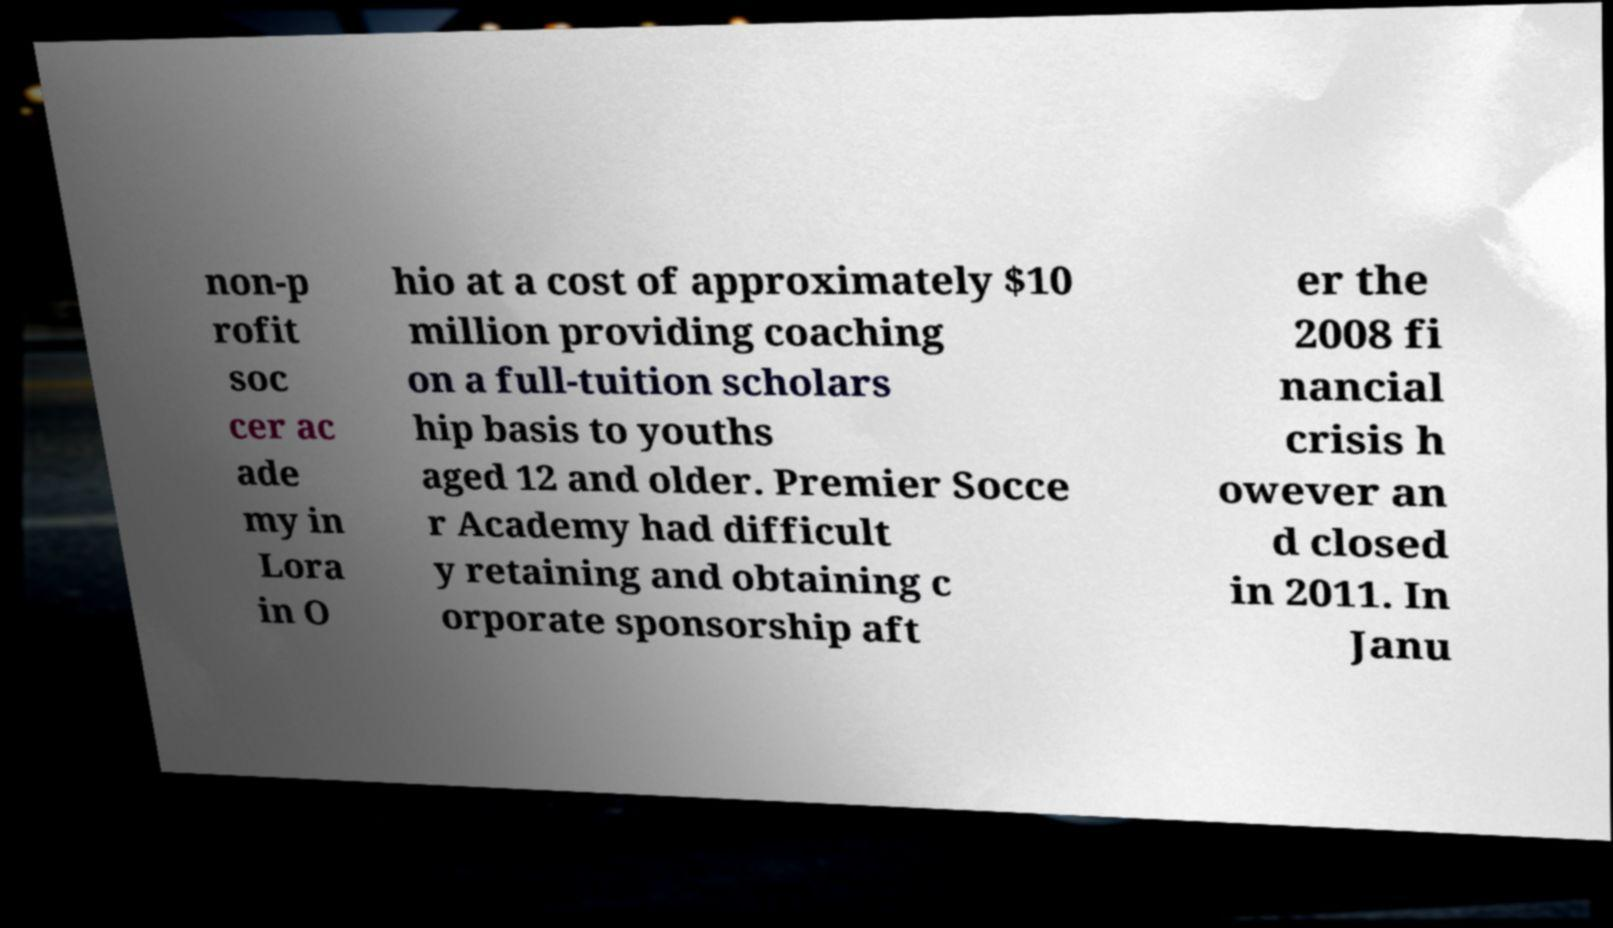Can you read and provide the text displayed in the image?This photo seems to have some interesting text. Can you extract and type it out for me? non-p rofit soc cer ac ade my in Lora in O hio at a cost of approximately $10 million providing coaching on a full-tuition scholars hip basis to youths aged 12 and older. Premier Socce r Academy had difficult y retaining and obtaining c orporate sponsorship aft er the 2008 fi nancial crisis h owever an d closed in 2011. In Janu 